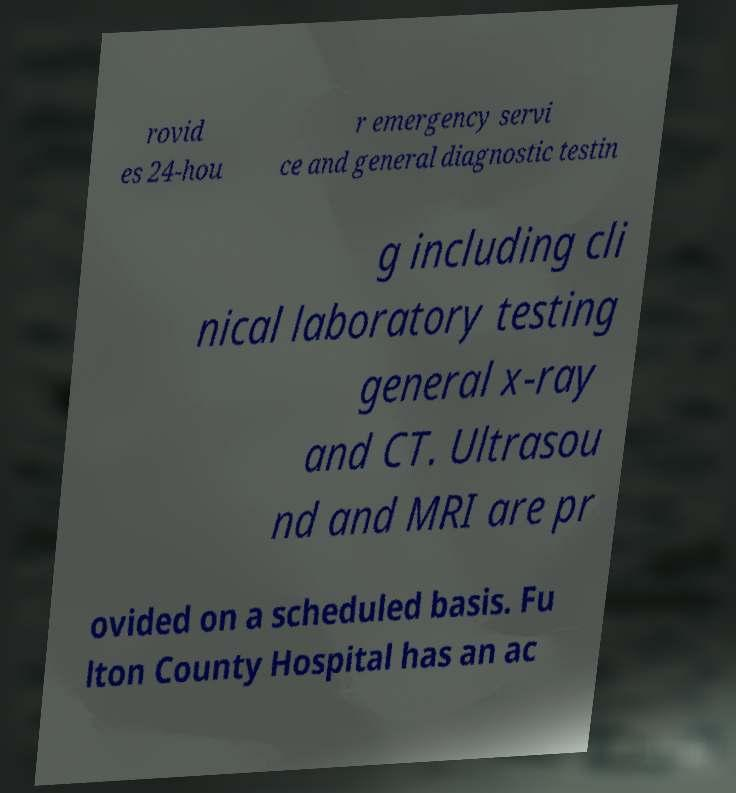Can you accurately transcribe the text from the provided image for me? rovid es 24-hou r emergency servi ce and general diagnostic testin g including cli nical laboratory testing general x-ray and CT. Ultrasou nd and MRI are pr ovided on a scheduled basis. Fu lton County Hospital has an ac 